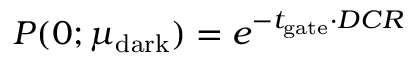Convert formula to latex. <formula><loc_0><loc_0><loc_500><loc_500>P ( 0 ; \mu _ { d a r k } ) = e ^ { - t _ { g a t e } \cdot D C R }</formula> 